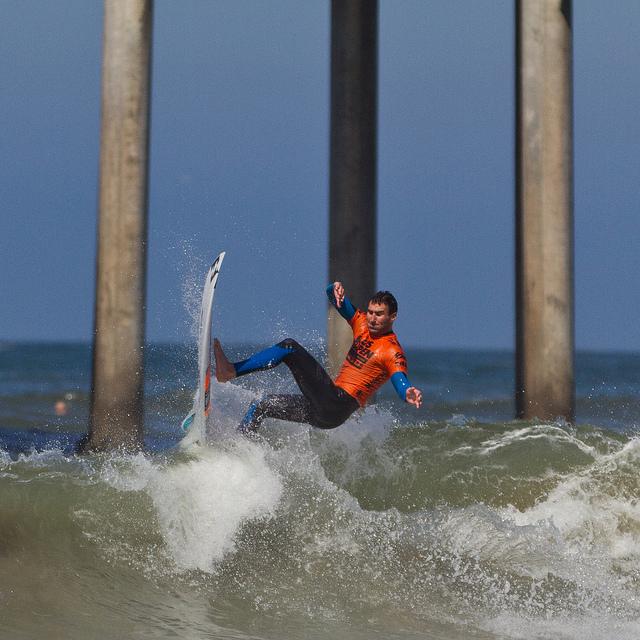Is it safe to surf so close to those pillars?
Answer briefly. No. Is he in a contest?
Give a very brief answer. No. Is this a contest?
Keep it brief. No. 